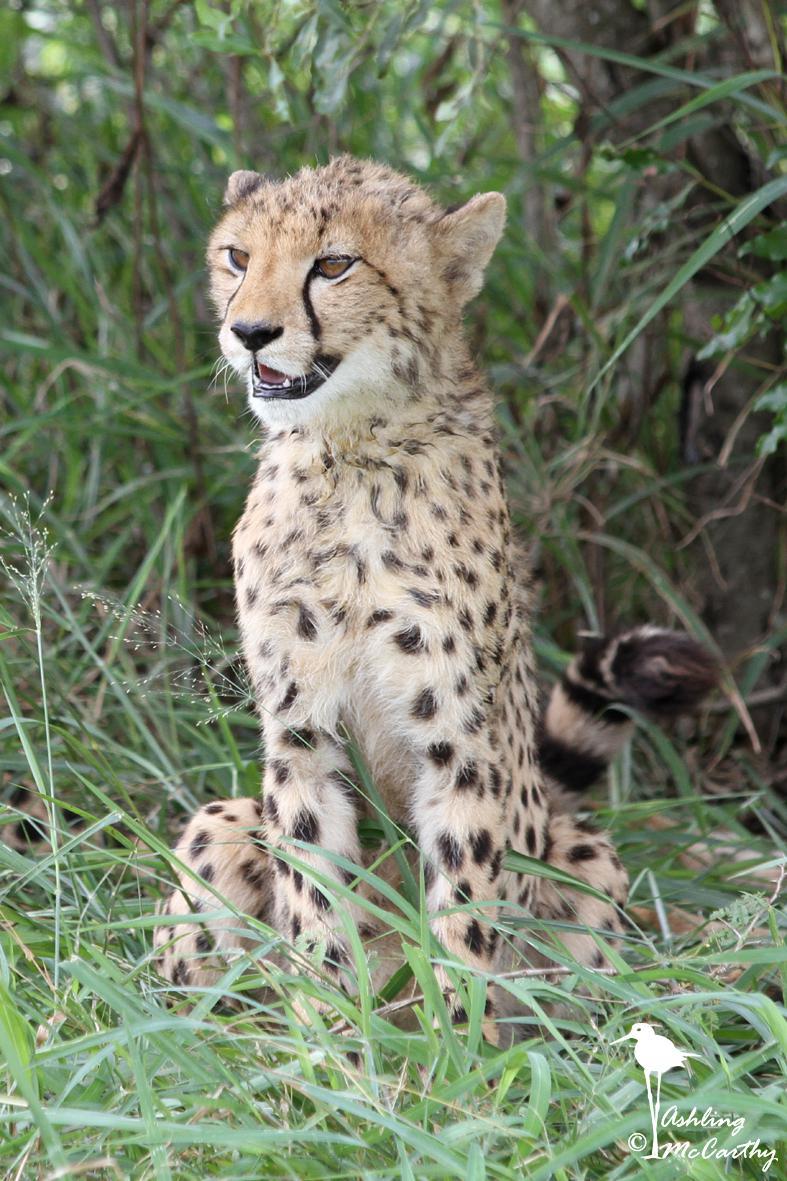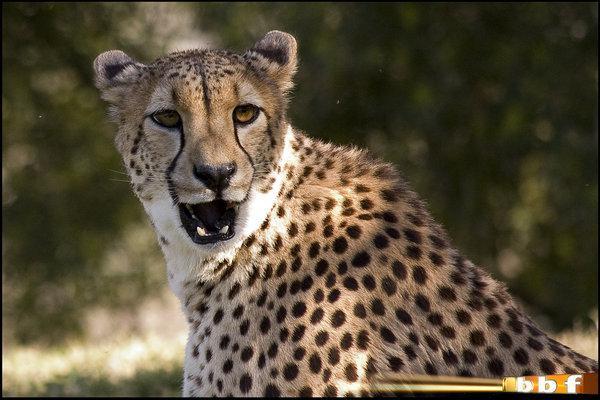The first image is the image on the left, the second image is the image on the right. Given the left and right images, does the statement "One image features exactly one young cheetah next to an adult cheetah sitting upright with its head and body facing right." hold true? Answer yes or no. No. The first image is the image on the left, the second image is the image on the right. Evaluate the accuracy of this statement regarding the images: "At least one baby cheetah is looking straight into the camera.". Is it true? Answer yes or no. No. 